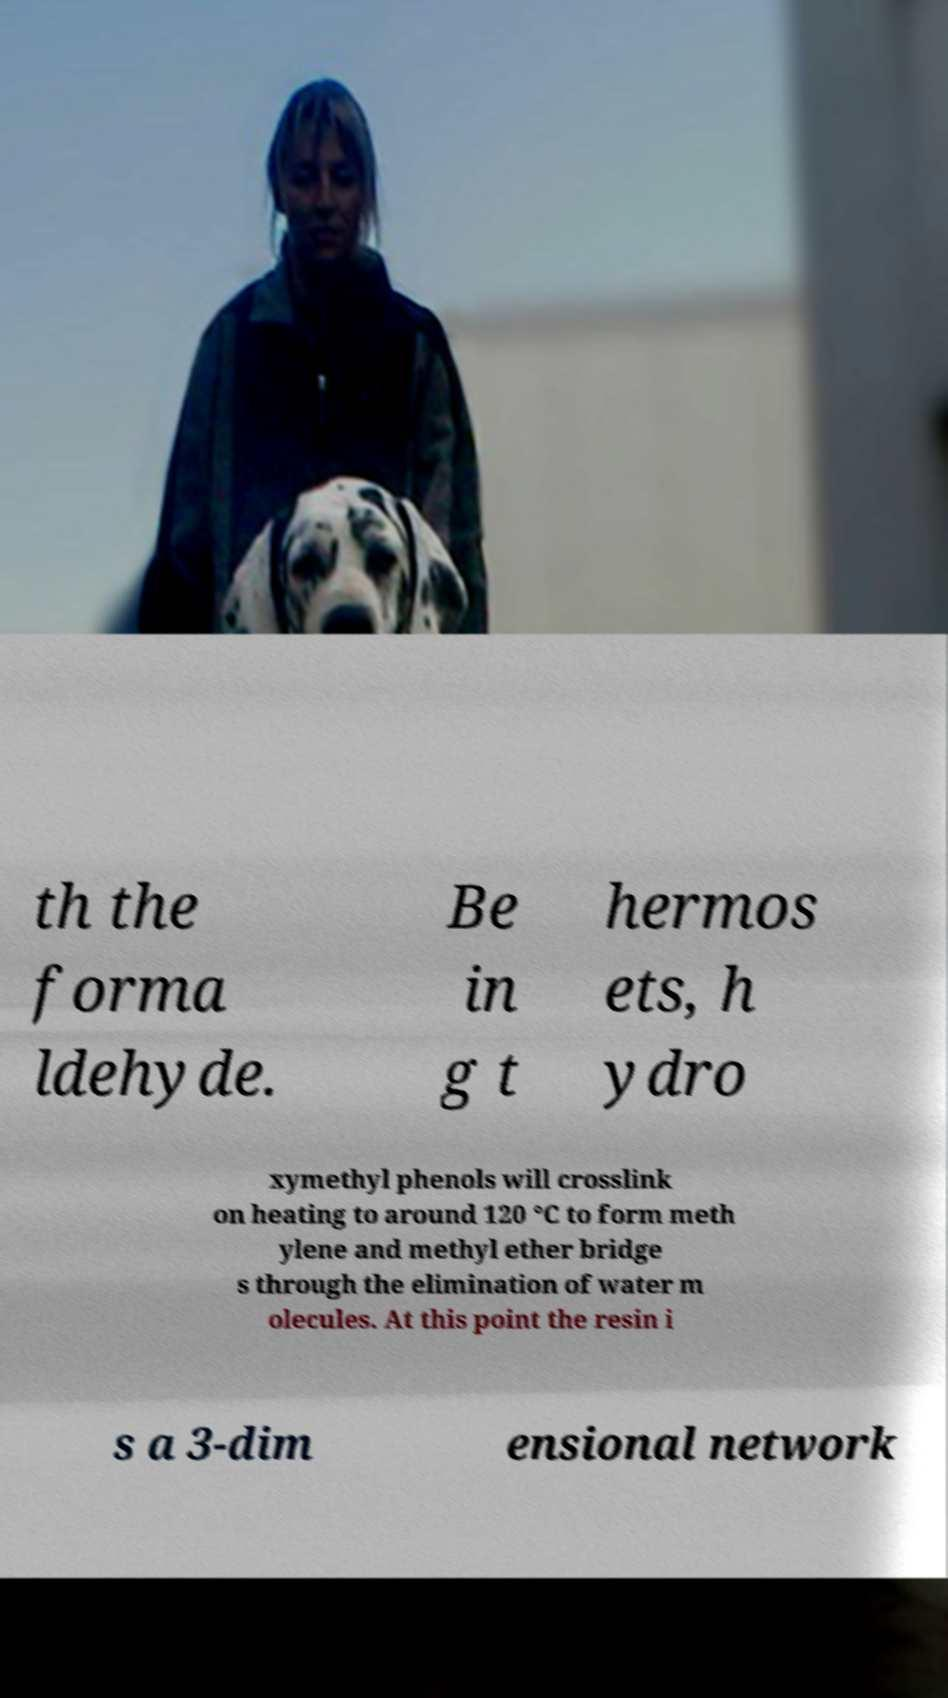Please read and relay the text visible in this image. What does it say? th the forma ldehyde. Be in g t hermos ets, h ydro xymethyl phenols will crosslink on heating to around 120 °C to form meth ylene and methyl ether bridge s through the elimination of water m olecules. At this point the resin i s a 3-dim ensional network 